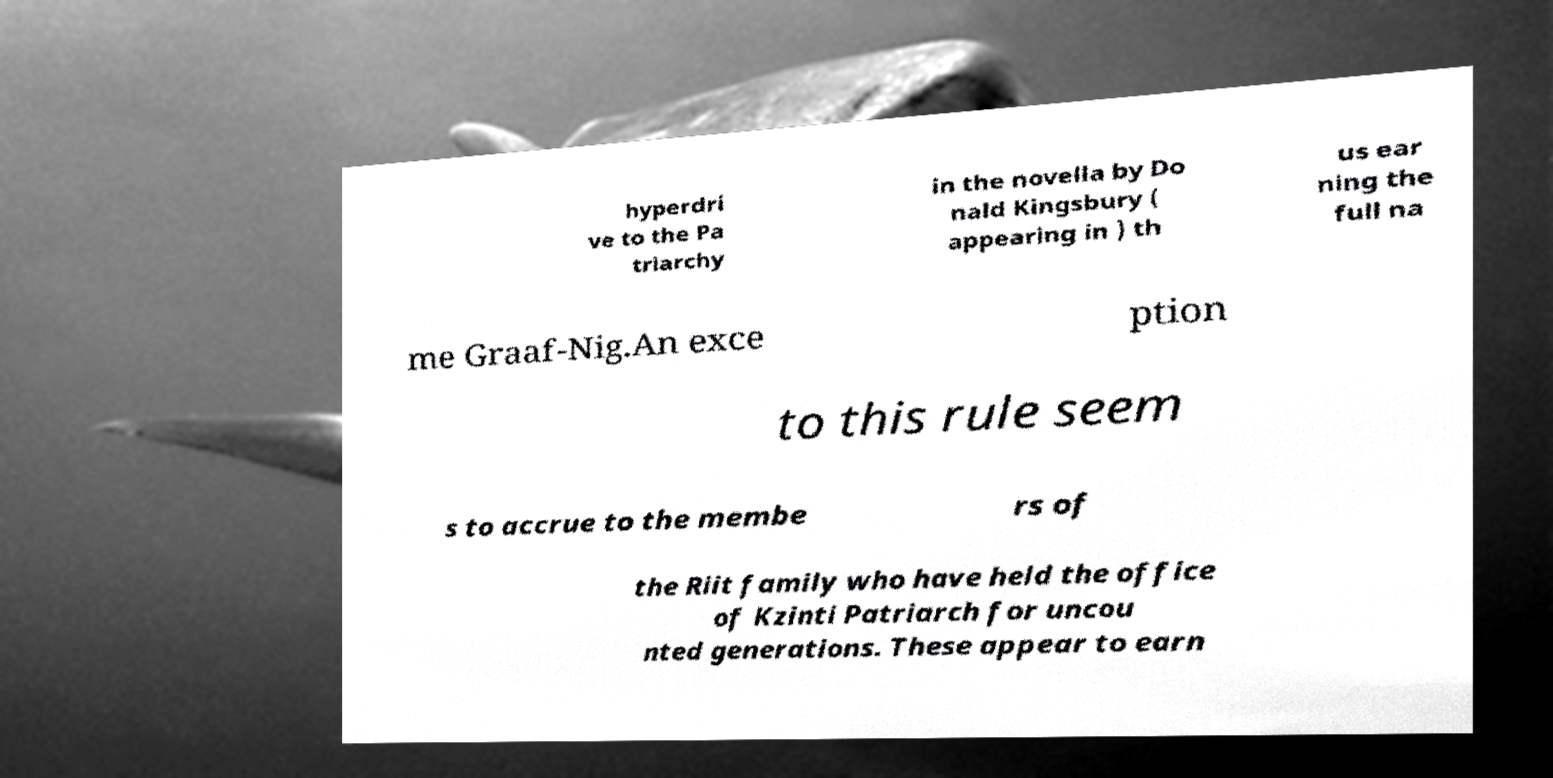Could you assist in decoding the text presented in this image and type it out clearly? hyperdri ve to the Pa triarchy in the novella by Do nald Kingsbury ( appearing in ) th us ear ning the full na me Graaf-Nig.An exce ption to this rule seem s to accrue to the membe rs of the Riit family who have held the office of Kzinti Patriarch for uncou nted generations. These appear to earn 